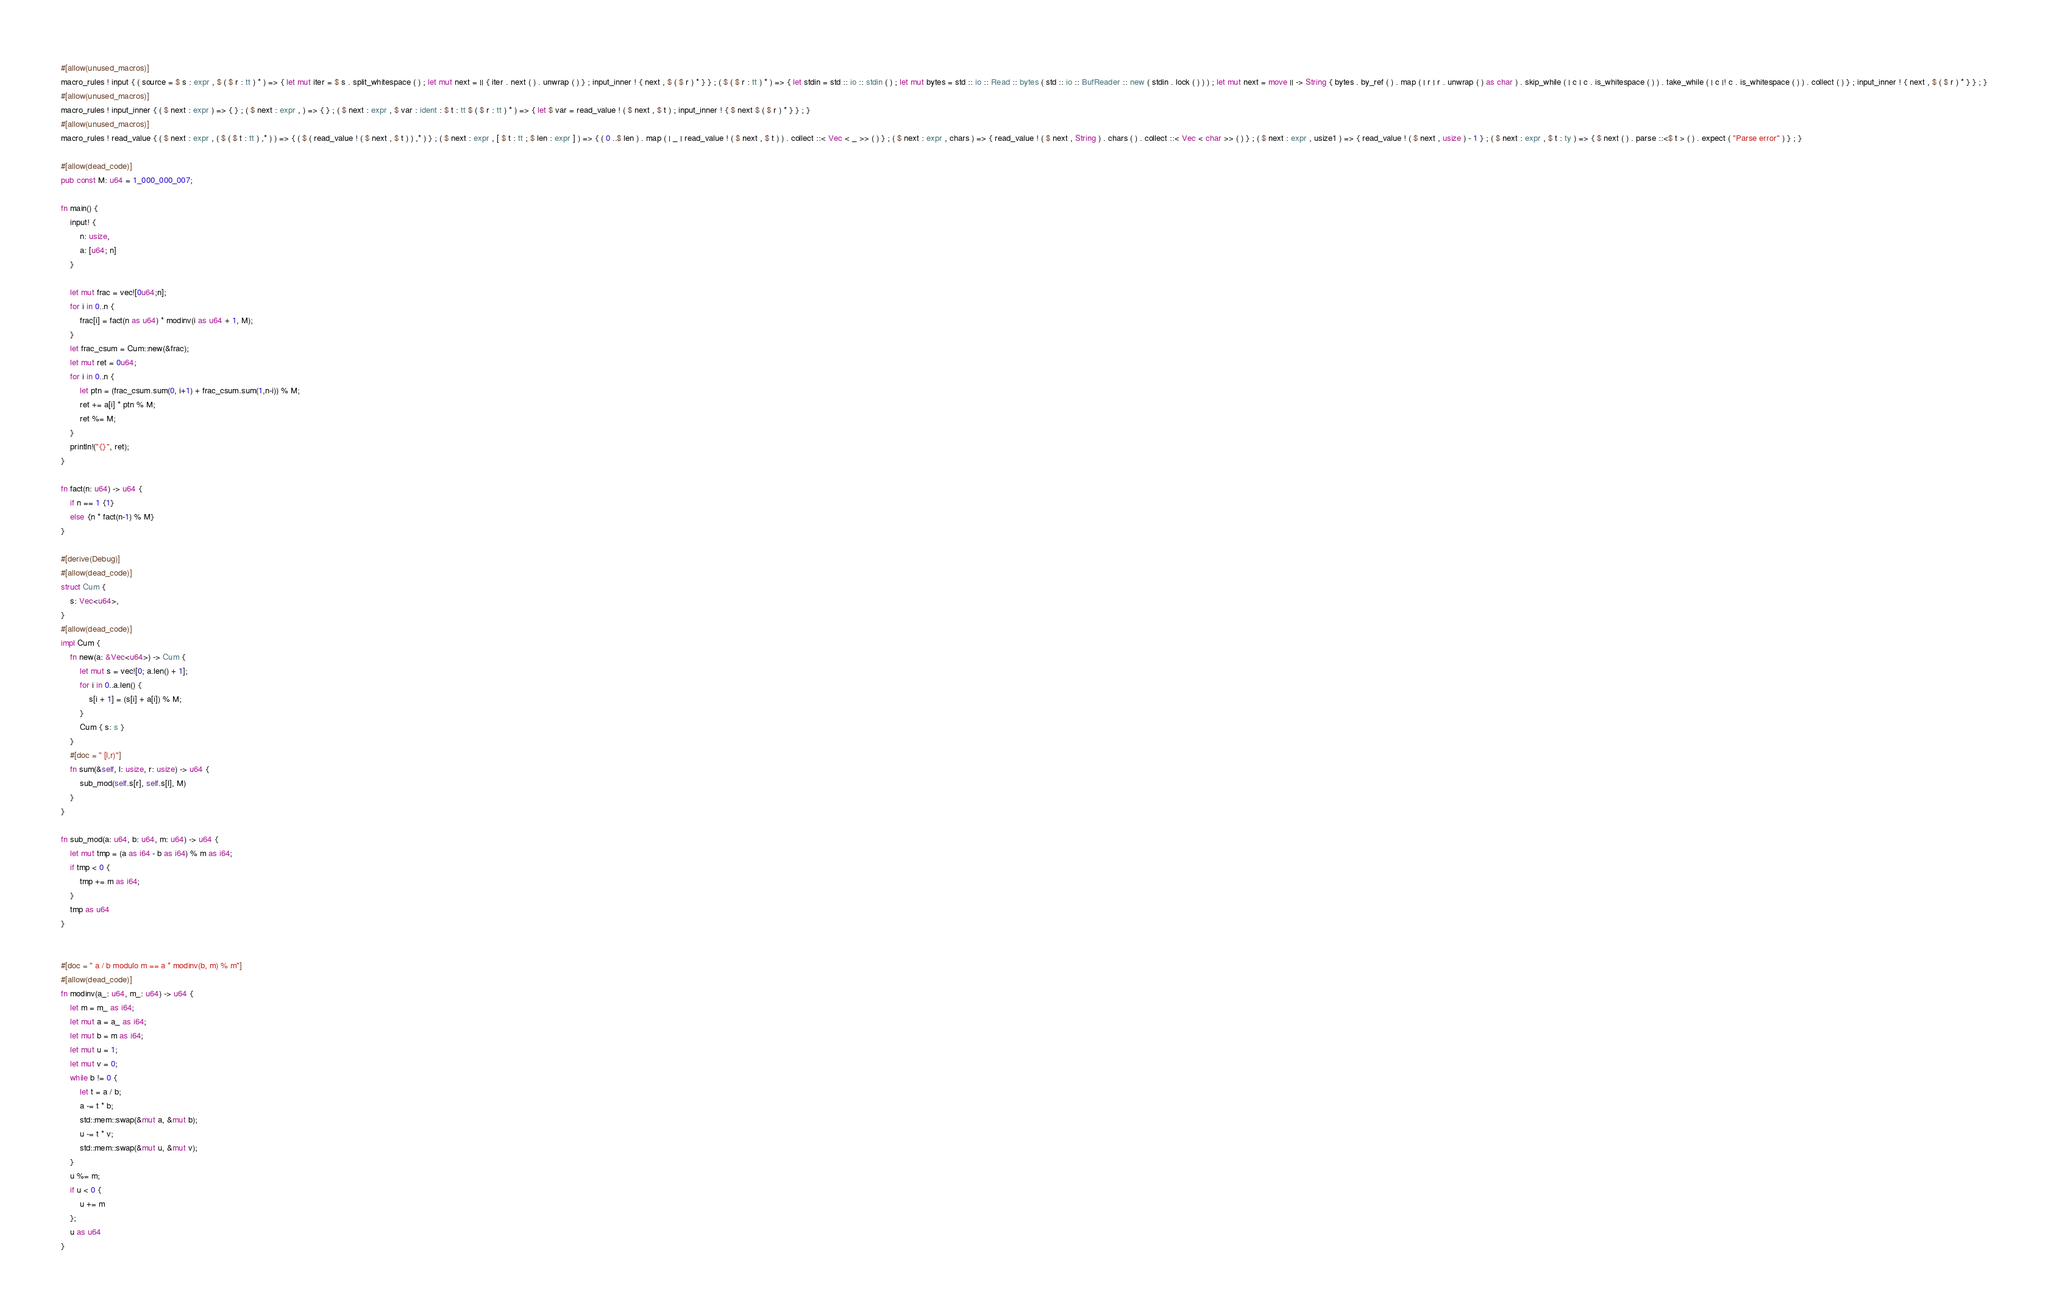<code> <loc_0><loc_0><loc_500><loc_500><_Rust_>#[allow(unused_macros)]
macro_rules ! input { ( source = $ s : expr , $ ( $ r : tt ) * ) => { let mut iter = $ s . split_whitespace ( ) ; let mut next = || { iter . next ( ) . unwrap ( ) } ; input_inner ! { next , $ ( $ r ) * } } ; ( $ ( $ r : tt ) * ) => { let stdin = std :: io :: stdin ( ) ; let mut bytes = std :: io :: Read :: bytes ( std :: io :: BufReader :: new ( stdin . lock ( ) ) ) ; let mut next = move || -> String { bytes . by_ref ( ) . map ( | r | r . unwrap ( ) as char ) . skip_while ( | c | c . is_whitespace ( ) ) . take_while ( | c |! c . is_whitespace ( ) ) . collect ( ) } ; input_inner ! { next , $ ( $ r ) * } } ; }
#[allow(unused_macros)]
macro_rules ! input_inner { ( $ next : expr ) => { } ; ( $ next : expr , ) => { } ; ( $ next : expr , $ var : ident : $ t : tt $ ( $ r : tt ) * ) => { let $ var = read_value ! ( $ next , $ t ) ; input_inner ! { $ next $ ( $ r ) * } } ; }
#[allow(unused_macros)]
macro_rules ! read_value { ( $ next : expr , ( $ ( $ t : tt ) ,* ) ) => { ( $ ( read_value ! ( $ next , $ t ) ) ,* ) } ; ( $ next : expr , [ $ t : tt ; $ len : expr ] ) => { ( 0 ..$ len ) . map ( | _ | read_value ! ( $ next , $ t ) ) . collect ::< Vec < _ >> ( ) } ; ( $ next : expr , chars ) => { read_value ! ( $ next , String ) . chars ( ) . collect ::< Vec < char >> ( ) } ; ( $ next : expr , usize1 ) => { read_value ! ( $ next , usize ) - 1 } ; ( $ next : expr , $ t : ty ) => { $ next ( ) . parse ::<$ t > ( ) . expect ( "Parse error" ) } ; }

#[allow(dead_code)]
pub const M: u64 = 1_000_000_007;

fn main() {
    input! {
        n: usize,
        a: [u64; n]
    }

    let mut frac = vec![0u64;n];
    for i in 0..n {
        frac[i] = fact(n as u64) * modinv(i as u64 + 1, M);
    }
    let frac_csum = Cum::new(&frac);
    let mut ret = 0u64;
    for i in 0..n {
        let ptn = (frac_csum.sum(0, i+1) + frac_csum.sum(1,n-i)) % M;
        ret += a[i] * ptn % M;
        ret %= M;
    }
    println!("{}", ret);
}

fn fact(n: u64) -> u64 {
    if n == 1 {1}
    else {n * fact(n-1) % M}
}

#[derive(Debug)]
#[allow(dead_code)]
struct Cum {
    s: Vec<u64>,
}
#[allow(dead_code)]
impl Cum {
    fn new(a: &Vec<u64>) -> Cum {
        let mut s = vec![0; a.len() + 1];
        for i in 0..a.len() {
            s[i + 1] = (s[i] + a[i]) % M;
        }
        Cum { s: s }
    }
    #[doc = " [l,r)"]
    fn sum(&self, l: usize, r: usize) -> u64 {
        sub_mod(self.s[r], self.s[l], M)
    }
}

fn sub_mod(a: u64, b: u64, m: u64) -> u64 {
    let mut tmp = (a as i64 - b as i64) % m as i64;
    if tmp < 0 {
        tmp += m as i64;
    }
    tmp as u64
}


#[doc = " a / b modulo m == a * modinv(b, m) % m"]
#[allow(dead_code)]
fn modinv(a_: u64, m_: u64) -> u64 {
    let m = m_ as i64;
    let mut a = a_ as i64;
    let mut b = m as i64;
    let mut u = 1;
    let mut v = 0;
    while b != 0 {
        let t = a / b;
        a -= t * b;
        std::mem::swap(&mut a, &mut b);
        u -= t * v;
        std::mem::swap(&mut u, &mut v);
    }
    u %= m;
    if u < 0 {
        u += m
    };
    u as u64
}</code> 